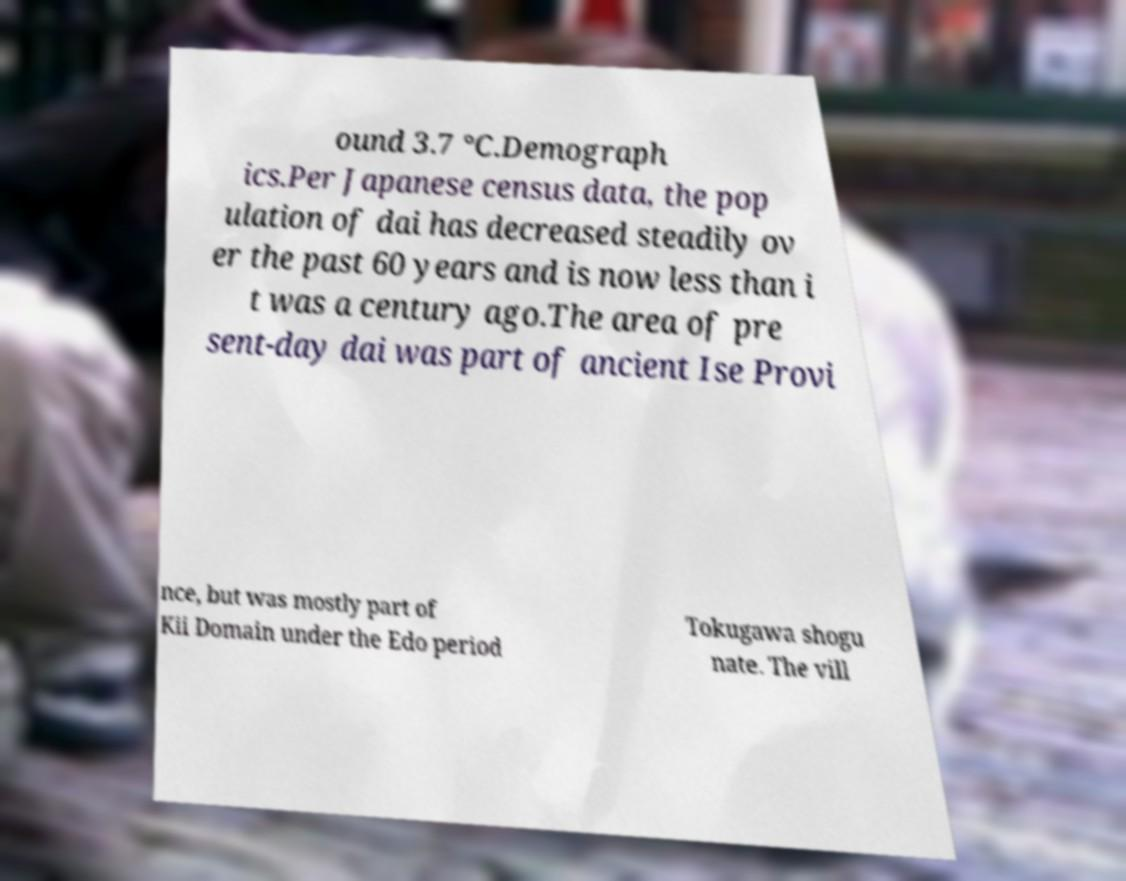Could you extract and type out the text from this image? ound 3.7 °C.Demograph ics.Per Japanese census data, the pop ulation of dai has decreased steadily ov er the past 60 years and is now less than i t was a century ago.The area of pre sent-day dai was part of ancient Ise Provi nce, but was mostly part of Kii Domain under the Edo period Tokugawa shogu nate. The vill 